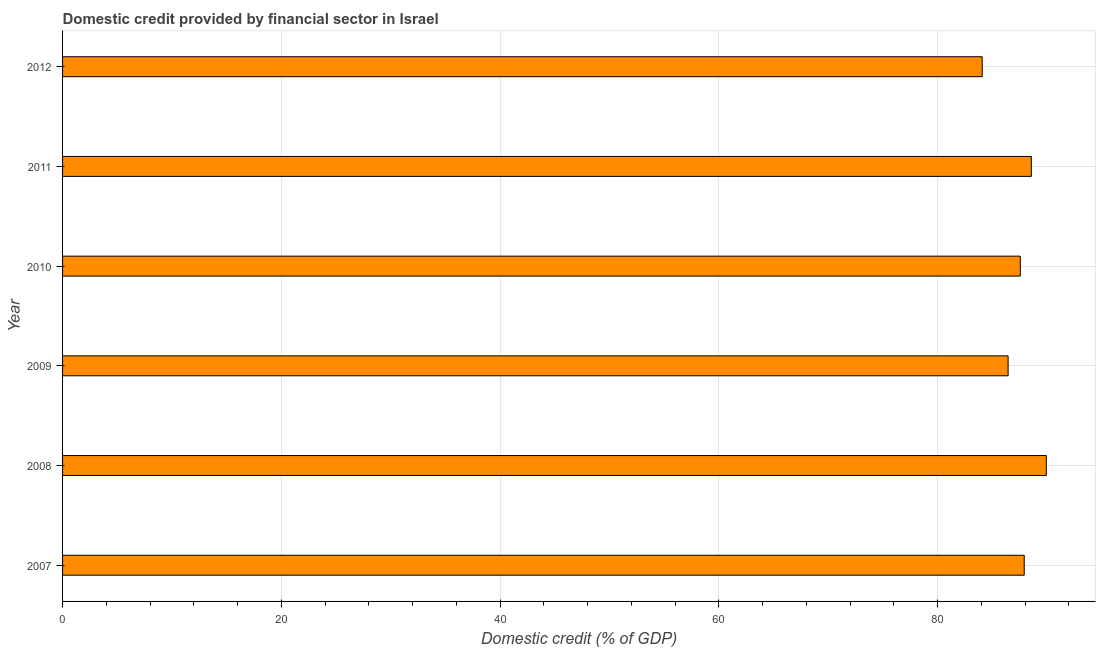What is the title of the graph?
Give a very brief answer. Domestic credit provided by financial sector in Israel. What is the label or title of the X-axis?
Offer a terse response. Domestic credit (% of GDP). What is the label or title of the Y-axis?
Your answer should be compact. Year. What is the domestic credit provided by financial sector in 2011?
Offer a very short reply. 88.57. Across all years, what is the maximum domestic credit provided by financial sector?
Make the answer very short. 89.94. Across all years, what is the minimum domestic credit provided by financial sector?
Provide a short and direct response. 84.08. In which year was the domestic credit provided by financial sector minimum?
Provide a short and direct response. 2012. What is the sum of the domestic credit provided by financial sector?
Ensure brevity in your answer.  524.52. What is the difference between the domestic credit provided by financial sector in 2009 and 2011?
Make the answer very short. -2.12. What is the average domestic credit provided by financial sector per year?
Your answer should be very brief. 87.42. What is the median domestic credit provided by financial sector?
Give a very brief answer. 87.74. In how many years, is the domestic credit provided by financial sector greater than 68 %?
Give a very brief answer. 6. Do a majority of the years between 2009 and 2010 (inclusive) have domestic credit provided by financial sector greater than 76 %?
Your response must be concise. Yes. What is the ratio of the domestic credit provided by financial sector in 2008 to that in 2012?
Provide a short and direct response. 1.07. Is the difference between the domestic credit provided by financial sector in 2007 and 2011 greater than the difference between any two years?
Offer a terse response. No. What is the difference between the highest and the second highest domestic credit provided by financial sector?
Offer a very short reply. 1.37. Is the sum of the domestic credit provided by financial sector in 2008 and 2009 greater than the maximum domestic credit provided by financial sector across all years?
Offer a terse response. Yes. What is the difference between the highest and the lowest domestic credit provided by financial sector?
Your answer should be very brief. 5.86. How many bars are there?
Provide a short and direct response. 6. Are all the bars in the graph horizontal?
Your answer should be compact. Yes. What is the Domestic credit (% of GDP) in 2007?
Ensure brevity in your answer.  87.92. What is the Domestic credit (% of GDP) of 2008?
Your answer should be very brief. 89.94. What is the Domestic credit (% of GDP) in 2009?
Provide a succinct answer. 86.45. What is the Domestic credit (% of GDP) of 2010?
Your response must be concise. 87.56. What is the Domestic credit (% of GDP) of 2011?
Give a very brief answer. 88.57. What is the Domestic credit (% of GDP) of 2012?
Your answer should be very brief. 84.08. What is the difference between the Domestic credit (% of GDP) in 2007 and 2008?
Offer a very short reply. -2.02. What is the difference between the Domestic credit (% of GDP) in 2007 and 2009?
Give a very brief answer. 1.47. What is the difference between the Domestic credit (% of GDP) in 2007 and 2010?
Ensure brevity in your answer.  0.36. What is the difference between the Domestic credit (% of GDP) in 2007 and 2011?
Offer a terse response. -0.65. What is the difference between the Domestic credit (% of GDP) in 2007 and 2012?
Make the answer very short. 3.84. What is the difference between the Domestic credit (% of GDP) in 2008 and 2009?
Keep it short and to the point. 3.49. What is the difference between the Domestic credit (% of GDP) in 2008 and 2010?
Offer a very short reply. 2.38. What is the difference between the Domestic credit (% of GDP) in 2008 and 2011?
Keep it short and to the point. 1.37. What is the difference between the Domestic credit (% of GDP) in 2008 and 2012?
Offer a terse response. 5.86. What is the difference between the Domestic credit (% of GDP) in 2009 and 2010?
Ensure brevity in your answer.  -1.12. What is the difference between the Domestic credit (% of GDP) in 2009 and 2011?
Provide a short and direct response. -2.12. What is the difference between the Domestic credit (% of GDP) in 2009 and 2012?
Offer a terse response. 2.37. What is the difference between the Domestic credit (% of GDP) in 2010 and 2011?
Your answer should be very brief. -1.01. What is the difference between the Domestic credit (% of GDP) in 2010 and 2012?
Provide a short and direct response. 3.48. What is the difference between the Domestic credit (% of GDP) in 2011 and 2012?
Keep it short and to the point. 4.49. What is the ratio of the Domestic credit (% of GDP) in 2007 to that in 2008?
Offer a terse response. 0.98. What is the ratio of the Domestic credit (% of GDP) in 2007 to that in 2012?
Ensure brevity in your answer.  1.05. What is the ratio of the Domestic credit (% of GDP) in 2008 to that in 2009?
Ensure brevity in your answer.  1.04. What is the ratio of the Domestic credit (% of GDP) in 2008 to that in 2012?
Your answer should be very brief. 1.07. What is the ratio of the Domestic credit (% of GDP) in 2009 to that in 2010?
Keep it short and to the point. 0.99. What is the ratio of the Domestic credit (% of GDP) in 2009 to that in 2011?
Offer a very short reply. 0.98. What is the ratio of the Domestic credit (% of GDP) in 2009 to that in 2012?
Provide a short and direct response. 1.03. What is the ratio of the Domestic credit (% of GDP) in 2010 to that in 2011?
Make the answer very short. 0.99. What is the ratio of the Domestic credit (% of GDP) in 2010 to that in 2012?
Provide a succinct answer. 1.04. What is the ratio of the Domestic credit (% of GDP) in 2011 to that in 2012?
Offer a very short reply. 1.05. 